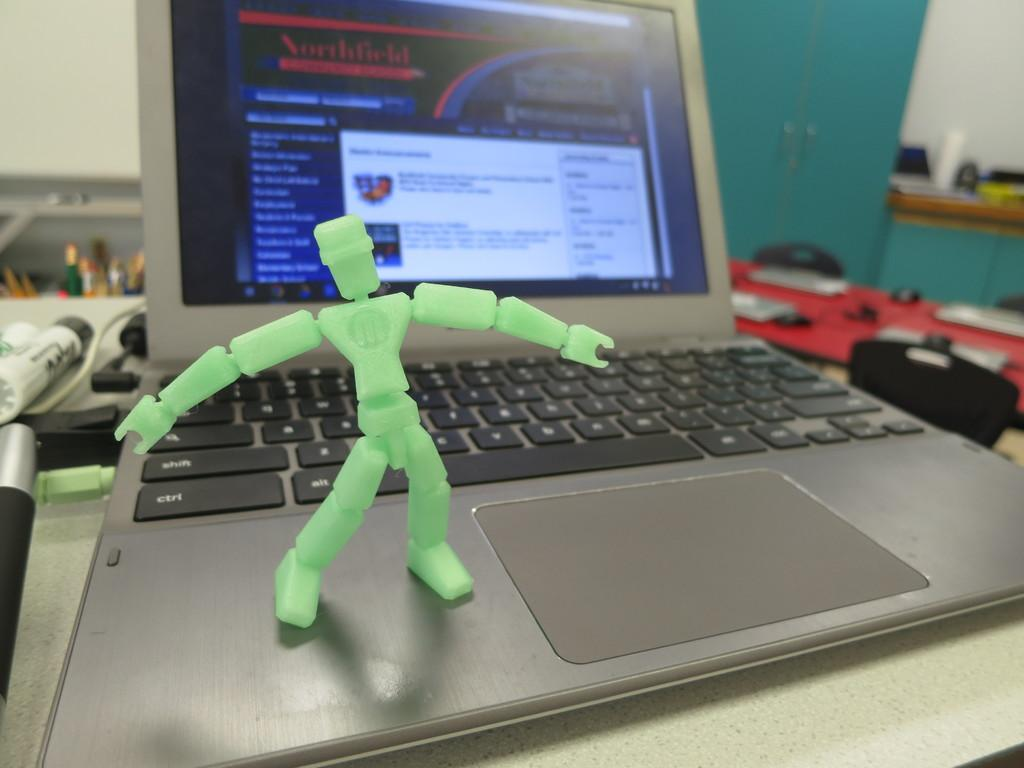<image>
Summarize the visual content of the image. a green figure with letter M on the body is standing on a laptop 